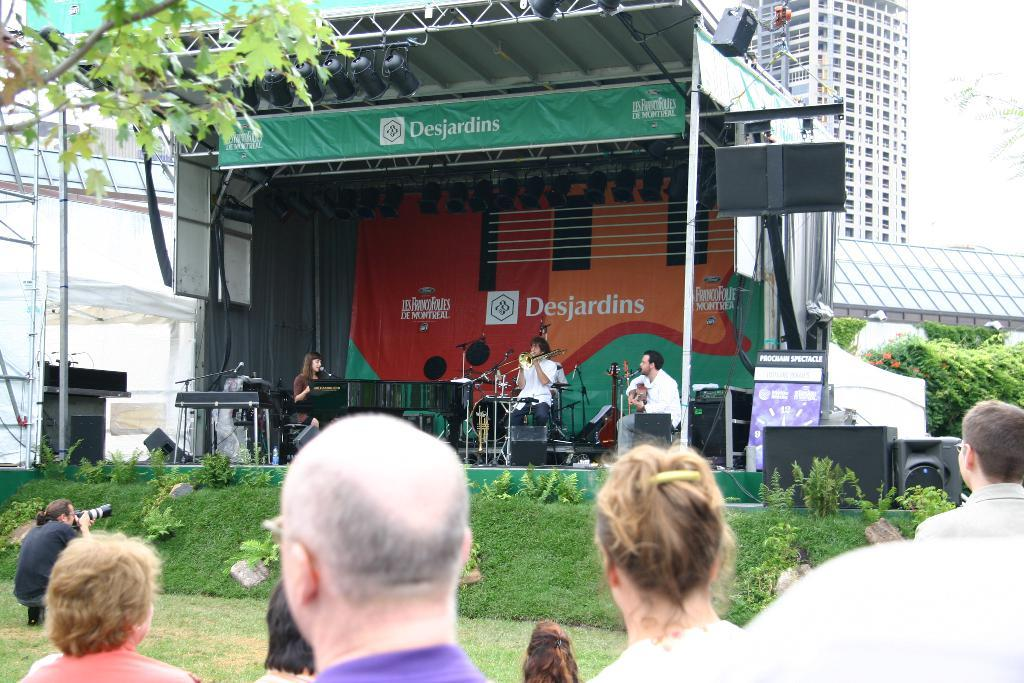How many people are in the group visible in the image? There is a group of people in the image, but the exact number cannot be determined from the provided facts. What type of structure is present in the image? There is a shelter in the image. What are the people in the group doing? The presence of musical instruments suggests that they might be playing music. What type of vegetation is visible in the image? There are trees and plants in the image. What else can be seen in the image besides the people and shelter? There are objects in the image, but their specific nature cannot be determined from the provided facts. What can be seen in the background of the image? There are buildings in the background of the image. What type of shoe is visible on the button in the image? There is no shoe or button present in the image. What sound does the alarm make in the image? There is no alarm present in the image. 